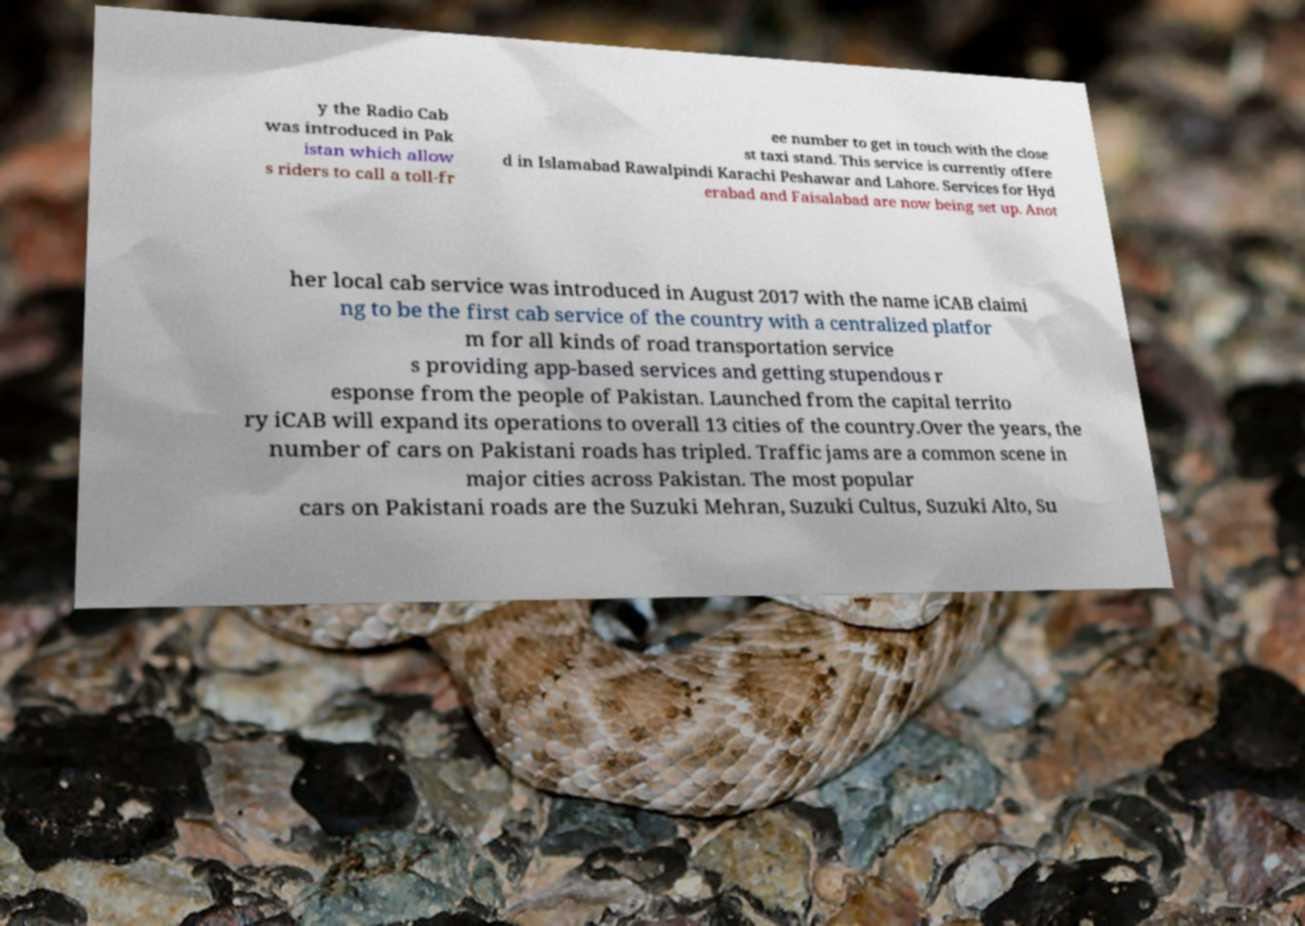Please identify and transcribe the text found in this image. y the Radio Cab was introduced in Pak istan which allow s riders to call a toll-fr ee number to get in touch with the close st taxi stand. This service is currently offere d in Islamabad Rawalpindi Karachi Peshawar and Lahore. Services for Hyd erabad and Faisalabad are now being set up. Anot her local cab service was introduced in August 2017 with the name iCAB claimi ng to be the first cab service of the country with a centralized platfor m for all kinds of road transportation service s providing app-based services and getting stupendous r esponse from the people of Pakistan. Launched from the capital territo ry iCAB will expand its operations to overall 13 cities of the country.Over the years, the number of cars on Pakistani roads has tripled. Traffic jams are a common scene in major cities across Pakistan. The most popular cars on Pakistani roads are the Suzuki Mehran, Suzuki Cultus, Suzuki Alto, Su 